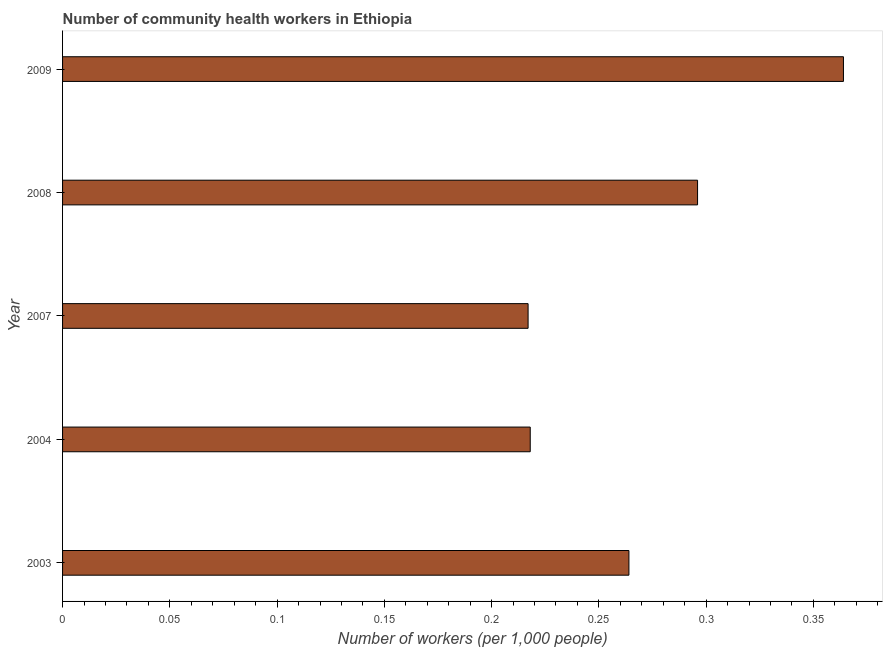Does the graph contain any zero values?
Provide a succinct answer. No. What is the title of the graph?
Ensure brevity in your answer.  Number of community health workers in Ethiopia. What is the label or title of the X-axis?
Make the answer very short. Number of workers (per 1,0 people). What is the number of community health workers in 2008?
Your answer should be compact. 0.3. Across all years, what is the maximum number of community health workers?
Provide a short and direct response. 0.36. Across all years, what is the minimum number of community health workers?
Provide a short and direct response. 0.22. In which year was the number of community health workers minimum?
Offer a very short reply. 2007. What is the sum of the number of community health workers?
Your response must be concise. 1.36. What is the difference between the number of community health workers in 2007 and 2009?
Offer a very short reply. -0.15. What is the average number of community health workers per year?
Provide a succinct answer. 0.27. What is the median number of community health workers?
Provide a succinct answer. 0.26. In how many years, is the number of community health workers greater than 0.16 ?
Your answer should be compact. 5. What is the ratio of the number of community health workers in 2003 to that in 2004?
Your response must be concise. 1.21. Is the difference between the number of community health workers in 2008 and 2009 greater than the difference between any two years?
Keep it short and to the point. No. What is the difference between the highest and the second highest number of community health workers?
Your response must be concise. 0.07. Is the sum of the number of community health workers in 2003 and 2007 greater than the maximum number of community health workers across all years?
Keep it short and to the point. Yes. In how many years, is the number of community health workers greater than the average number of community health workers taken over all years?
Offer a very short reply. 2. How many years are there in the graph?
Offer a terse response. 5. Are the values on the major ticks of X-axis written in scientific E-notation?
Make the answer very short. No. What is the Number of workers (per 1,000 people) of 2003?
Provide a short and direct response. 0.26. What is the Number of workers (per 1,000 people) in 2004?
Keep it short and to the point. 0.22. What is the Number of workers (per 1,000 people) in 2007?
Offer a terse response. 0.22. What is the Number of workers (per 1,000 people) of 2008?
Provide a short and direct response. 0.3. What is the Number of workers (per 1,000 people) in 2009?
Provide a succinct answer. 0.36. What is the difference between the Number of workers (per 1,000 people) in 2003 and 2004?
Your answer should be very brief. 0.05. What is the difference between the Number of workers (per 1,000 people) in 2003 and 2007?
Your response must be concise. 0.05. What is the difference between the Number of workers (per 1,000 people) in 2003 and 2008?
Make the answer very short. -0.03. What is the difference between the Number of workers (per 1,000 people) in 2003 and 2009?
Give a very brief answer. -0.1. What is the difference between the Number of workers (per 1,000 people) in 2004 and 2008?
Your answer should be compact. -0.08. What is the difference between the Number of workers (per 1,000 people) in 2004 and 2009?
Give a very brief answer. -0.15. What is the difference between the Number of workers (per 1,000 people) in 2007 and 2008?
Your answer should be very brief. -0.08. What is the difference between the Number of workers (per 1,000 people) in 2007 and 2009?
Your response must be concise. -0.15. What is the difference between the Number of workers (per 1,000 people) in 2008 and 2009?
Give a very brief answer. -0.07. What is the ratio of the Number of workers (per 1,000 people) in 2003 to that in 2004?
Your answer should be compact. 1.21. What is the ratio of the Number of workers (per 1,000 people) in 2003 to that in 2007?
Keep it short and to the point. 1.22. What is the ratio of the Number of workers (per 1,000 people) in 2003 to that in 2008?
Provide a short and direct response. 0.89. What is the ratio of the Number of workers (per 1,000 people) in 2003 to that in 2009?
Make the answer very short. 0.72. What is the ratio of the Number of workers (per 1,000 people) in 2004 to that in 2007?
Make the answer very short. 1. What is the ratio of the Number of workers (per 1,000 people) in 2004 to that in 2008?
Offer a very short reply. 0.74. What is the ratio of the Number of workers (per 1,000 people) in 2004 to that in 2009?
Ensure brevity in your answer.  0.6. What is the ratio of the Number of workers (per 1,000 people) in 2007 to that in 2008?
Keep it short and to the point. 0.73. What is the ratio of the Number of workers (per 1,000 people) in 2007 to that in 2009?
Give a very brief answer. 0.6. What is the ratio of the Number of workers (per 1,000 people) in 2008 to that in 2009?
Ensure brevity in your answer.  0.81. 